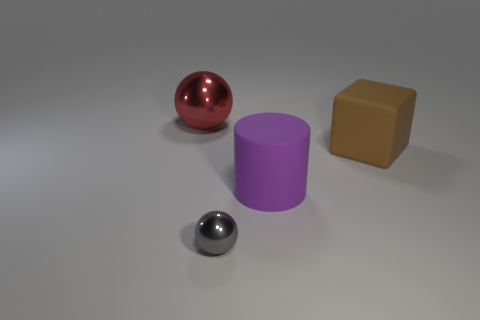Add 4 big rubber cylinders. How many objects exist? 8 Subtract all cubes. How many objects are left? 3 Add 2 big purple matte things. How many big purple matte things are left? 3 Add 1 red metallic things. How many red metallic things exist? 2 Subtract 0 gray blocks. How many objects are left? 4 Subtract all small cubes. Subtract all big purple cylinders. How many objects are left? 3 